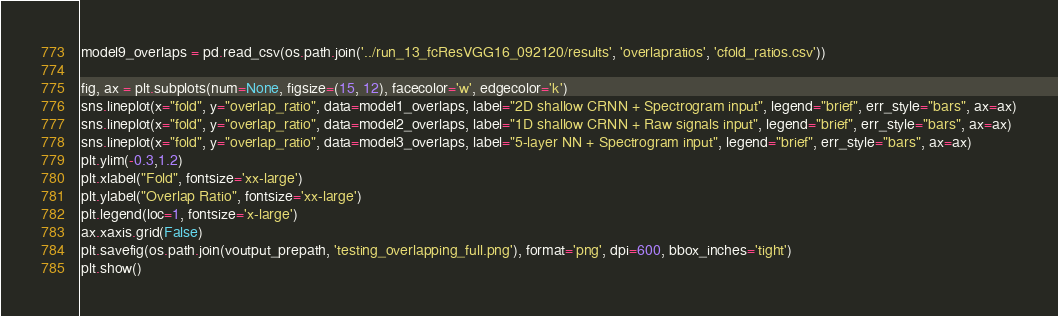<code> <loc_0><loc_0><loc_500><loc_500><_Python_>model9_overlaps = pd.read_csv(os.path.join('../run_13_fcResVGG16_092120/results', 'overlapratios', 'cfold_ratios.csv'))

fig, ax = plt.subplots(num=None, figsize=(15, 12), facecolor='w', edgecolor='k')
sns.lineplot(x="fold", y="overlap_ratio", data=model1_overlaps, label="2D shallow CRNN + Spectrogram input", legend="brief", err_style="bars", ax=ax)
sns.lineplot(x="fold", y="overlap_ratio", data=model2_overlaps, label="1D shallow CRNN + Raw signals input", legend="brief", err_style="bars", ax=ax)
sns.lineplot(x="fold", y="overlap_ratio", data=model3_overlaps, label="5-layer NN + Spectrogram input", legend="brief", err_style="bars", ax=ax)
plt.ylim(-0.3,1.2)
plt.xlabel("Fold", fontsize='xx-large')
plt.ylabel("Overlap Ratio", fontsize='xx-large')
plt.legend(loc=1, fontsize='x-large')
ax.xaxis.grid(False)
plt.savefig(os.path.join(voutput_prepath, 'testing_overlapping_full.png'), format='png', dpi=600, bbox_inches='tight')
plt.show()</code> 